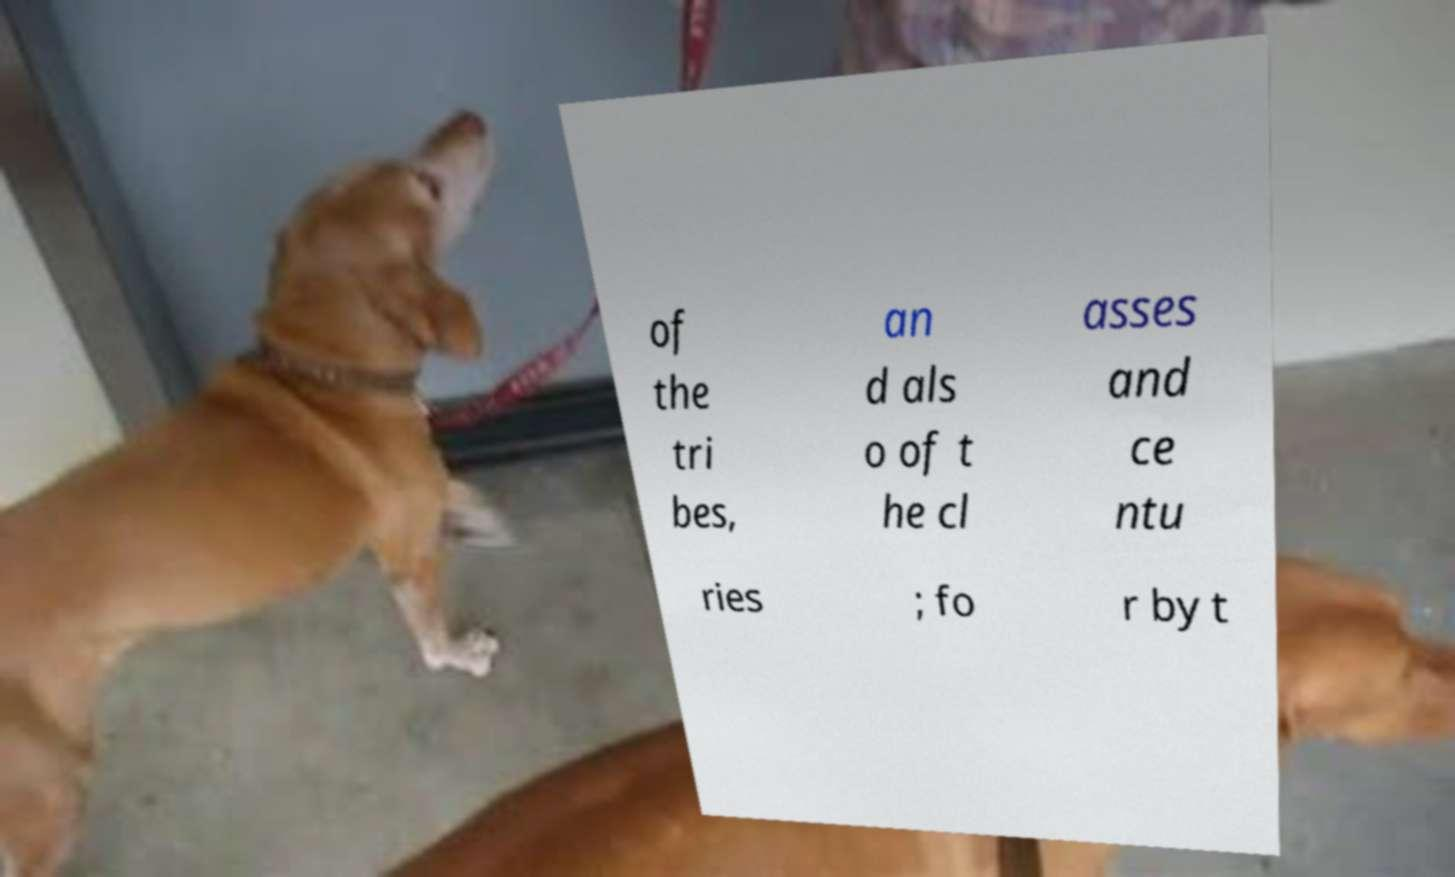For documentation purposes, I need the text within this image transcribed. Could you provide that? of the tri bes, an d als o of t he cl asses and ce ntu ries ; fo r by t 